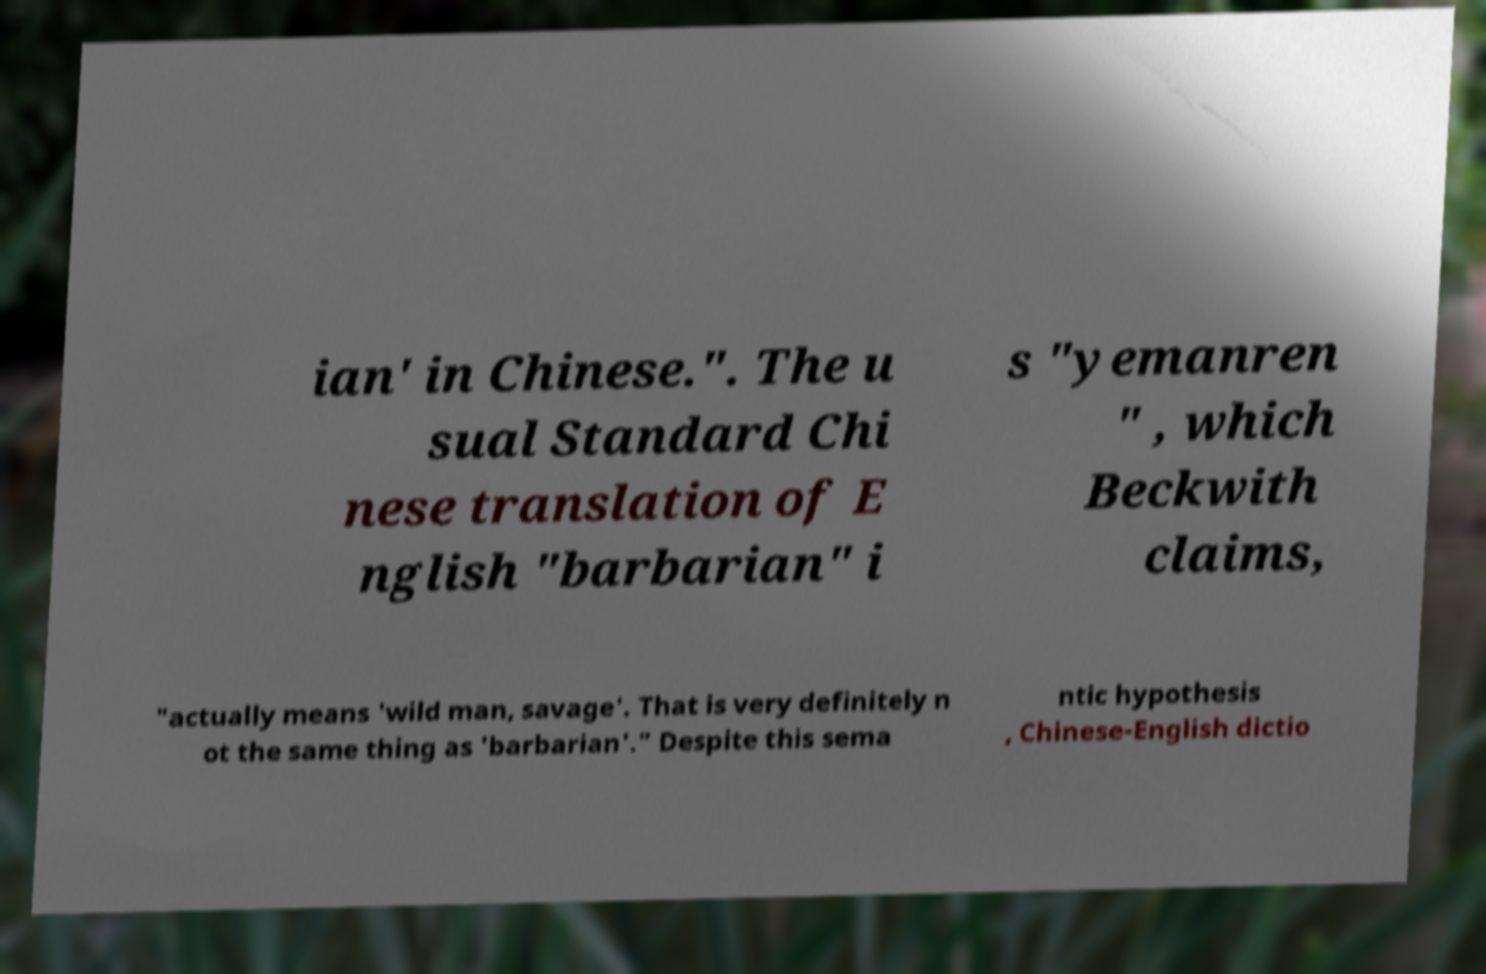Can you accurately transcribe the text from the provided image for me? ian' in Chinese.". The u sual Standard Chi nese translation of E nglish "barbarian" i s "yemanren " , which Beckwith claims, "actually means 'wild man, savage'. That is very definitely n ot the same thing as 'barbarian'." Despite this sema ntic hypothesis , Chinese-English dictio 